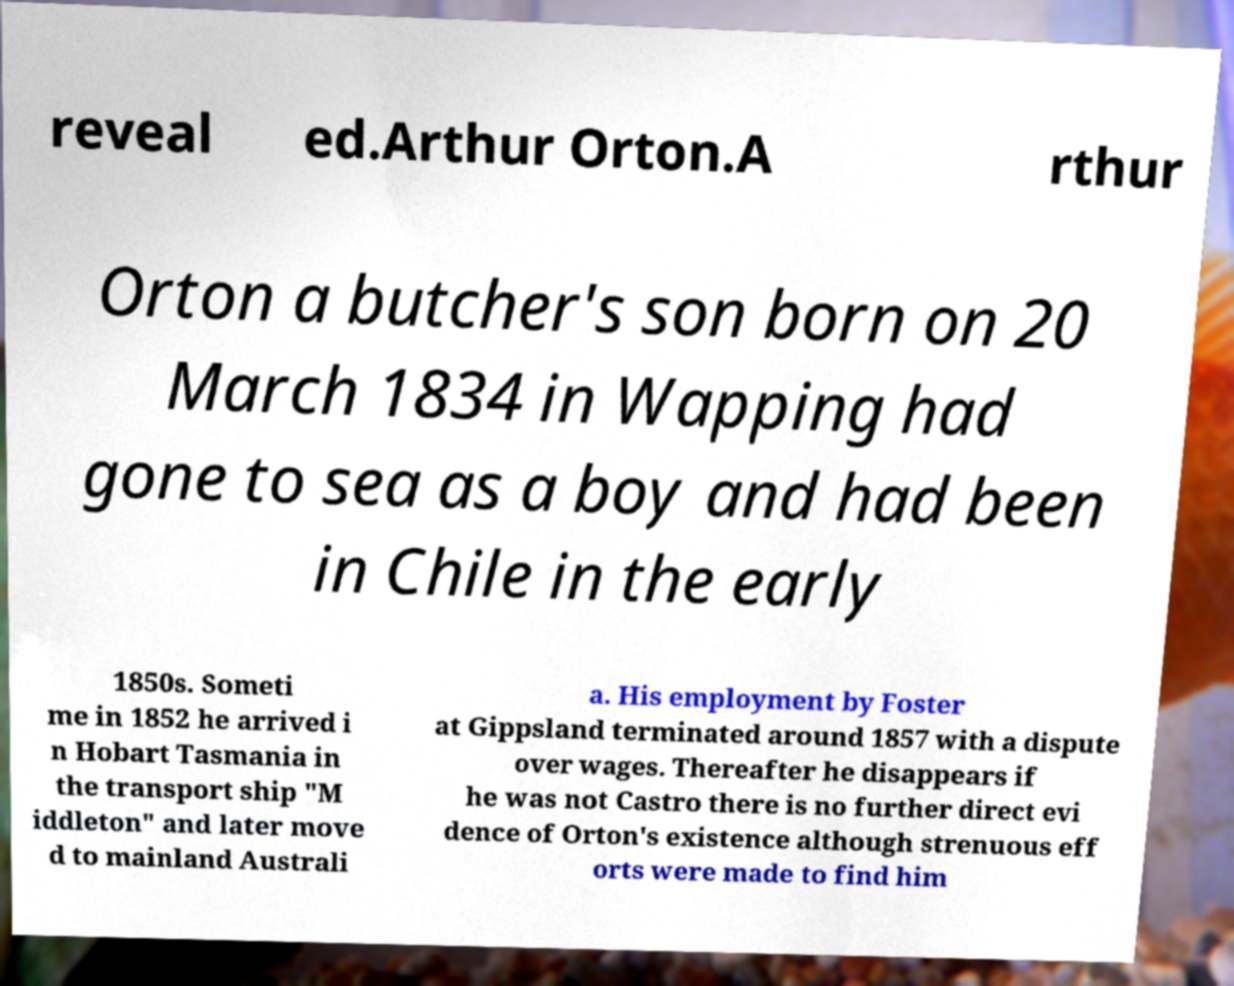For documentation purposes, I need the text within this image transcribed. Could you provide that? reveal ed.Arthur Orton.A rthur Orton a butcher's son born on 20 March 1834 in Wapping had gone to sea as a boy and had been in Chile in the early 1850s. Someti me in 1852 he arrived i n Hobart Tasmania in the transport ship "M iddleton" and later move d to mainland Australi a. His employment by Foster at Gippsland terminated around 1857 with a dispute over wages. Thereafter he disappears if he was not Castro there is no further direct evi dence of Orton's existence although strenuous eff orts were made to find him 